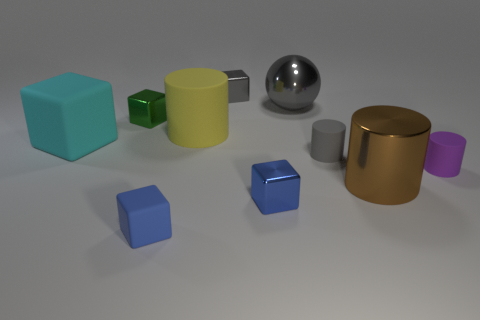Subtract all cyan blocks. How many blocks are left? 4 Subtract all purple matte cylinders. How many cylinders are left? 3 Subtract all purple cubes. Subtract all brown cylinders. How many cubes are left? 5 Subtract all cylinders. How many objects are left? 6 Add 5 big cyan cubes. How many big cyan cubes are left? 6 Add 10 big purple matte cylinders. How many big purple matte cylinders exist? 10 Subtract 0 purple spheres. How many objects are left? 10 Subtract all blue shiny cubes. Subtract all purple matte things. How many objects are left? 8 